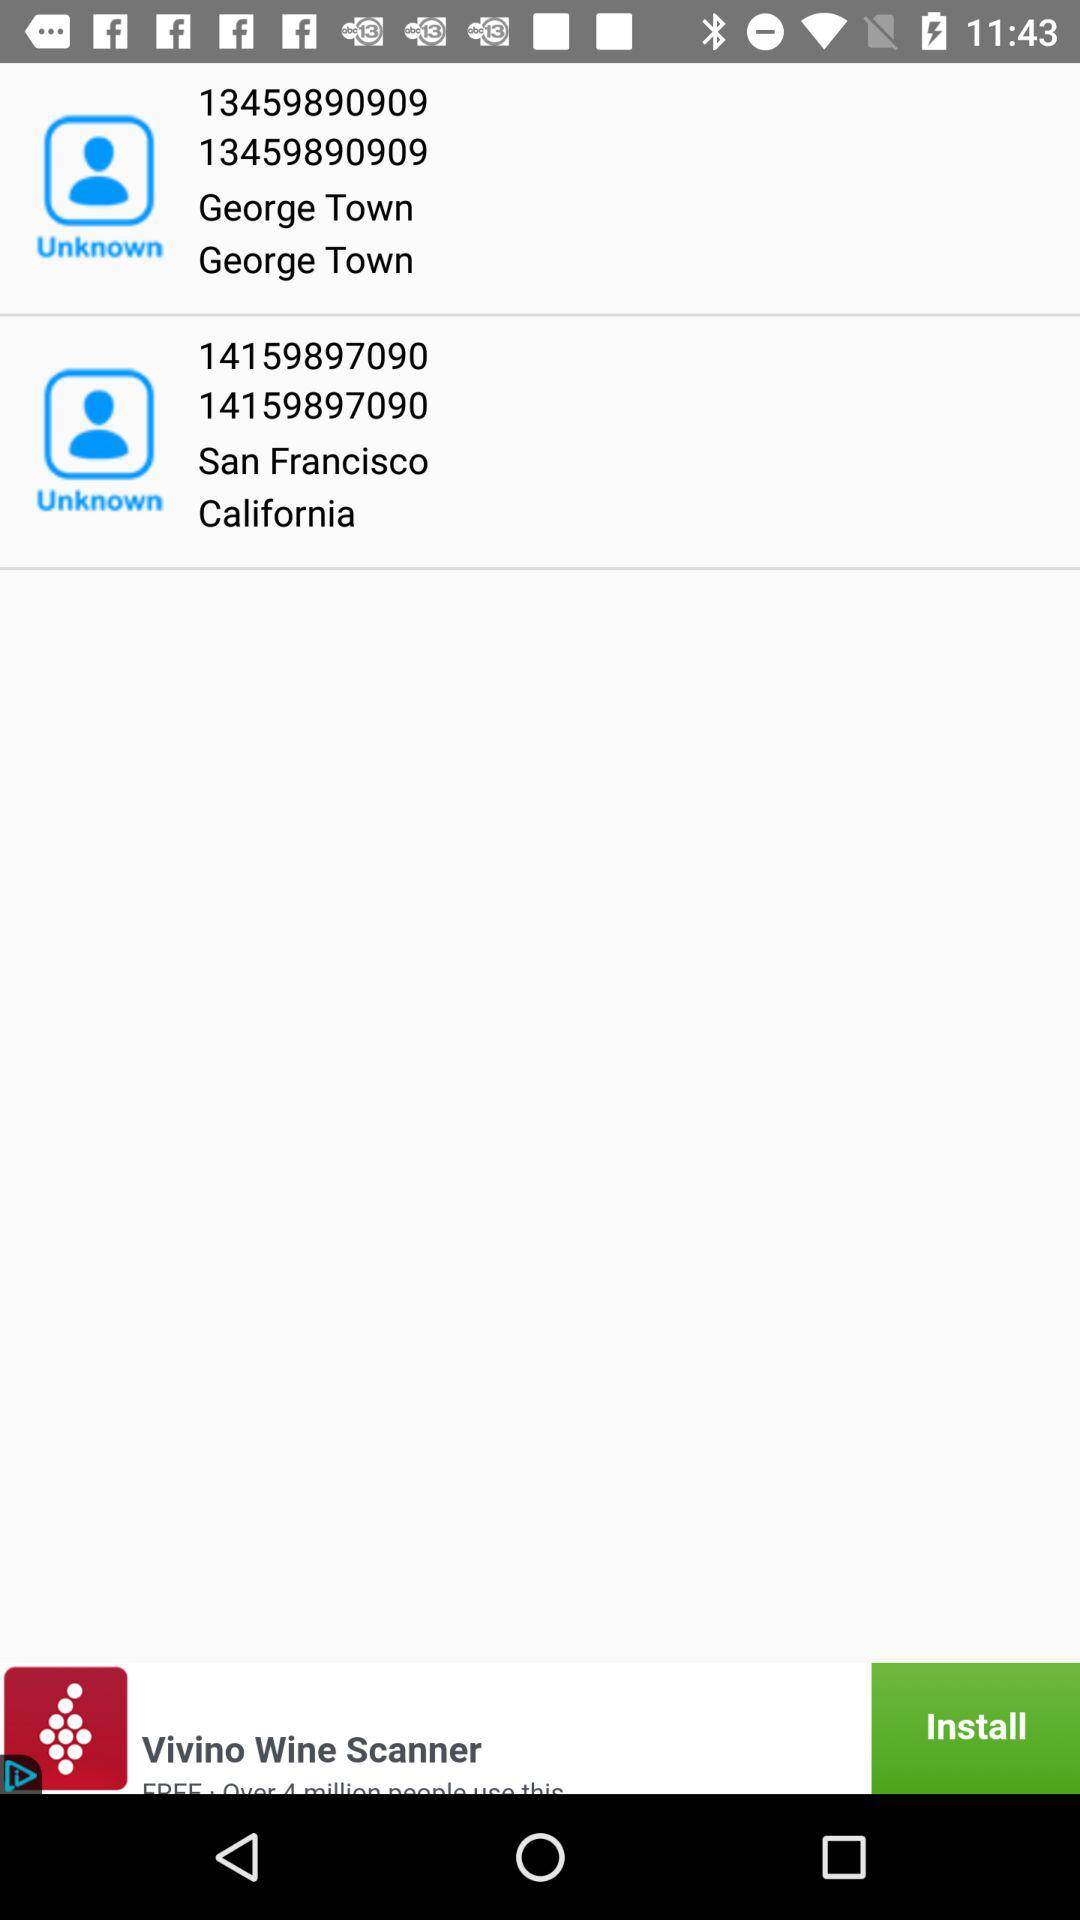How many contacts have a phone number?
Answer the question using a single word or phrase. 2 